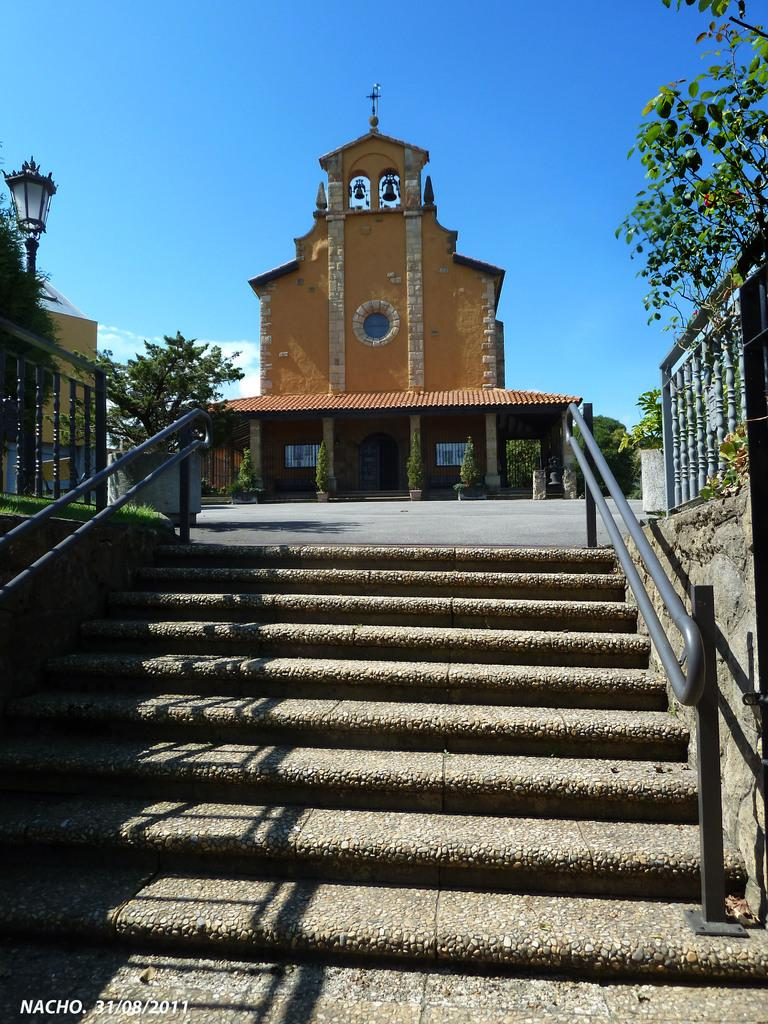What type of structure is visible in the image? There is a building in the image. What architectural feature can be seen at the bottom of the image? There are steps with railing at the bottom of the image. What type of vegetation is present on both sides of the image? There are trees on the left side and right side of the image. What is visible at the top of the image? The sky is visible at the top of the image. Can you describe the thrill experienced by the loaf of bread in the image? There is no loaf of bread present in the image, and therefore no thrill can be experienced or described. 